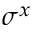<formula> <loc_0><loc_0><loc_500><loc_500>\sigma ^ { x }</formula> 